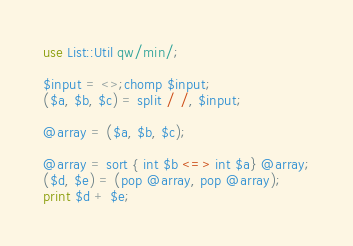<code> <loc_0><loc_0><loc_500><loc_500><_Perl_>use List::Util qw/min/;

$input = <>;chomp $input;
($a, $b, $c) = split / /, $input;

@array = ($a, $b, $c);

@array = sort { int $b <=> int $a} @array;
($d, $e) = (pop @array, pop @array);
print $d + $e;
</code> 